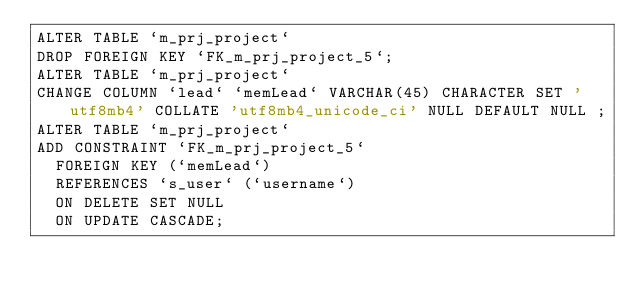<code> <loc_0><loc_0><loc_500><loc_500><_SQL_>ALTER TABLE `m_prj_project`
DROP FOREIGN KEY `FK_m_prj_project_5`;
ALTER TABLE `m_prj_project`
CHANGE COLUMN `lead` `memLead` VARCHAR(45) CHARACTER SET 'utf8mb4' COLLATE 'utf8mb4_unicode_ci' NULL DEFAULT NULL ;
ALTER TABLE `m_prj_project`
ADD CONSTRAINT `FK_m_prj_project_5`
  FOREIGN KEY (`memLead`)
  REFERENCES `s_user` (`username`)
  ON DELETE SET NULL
  ON UPDATE CASCADE;</code> 